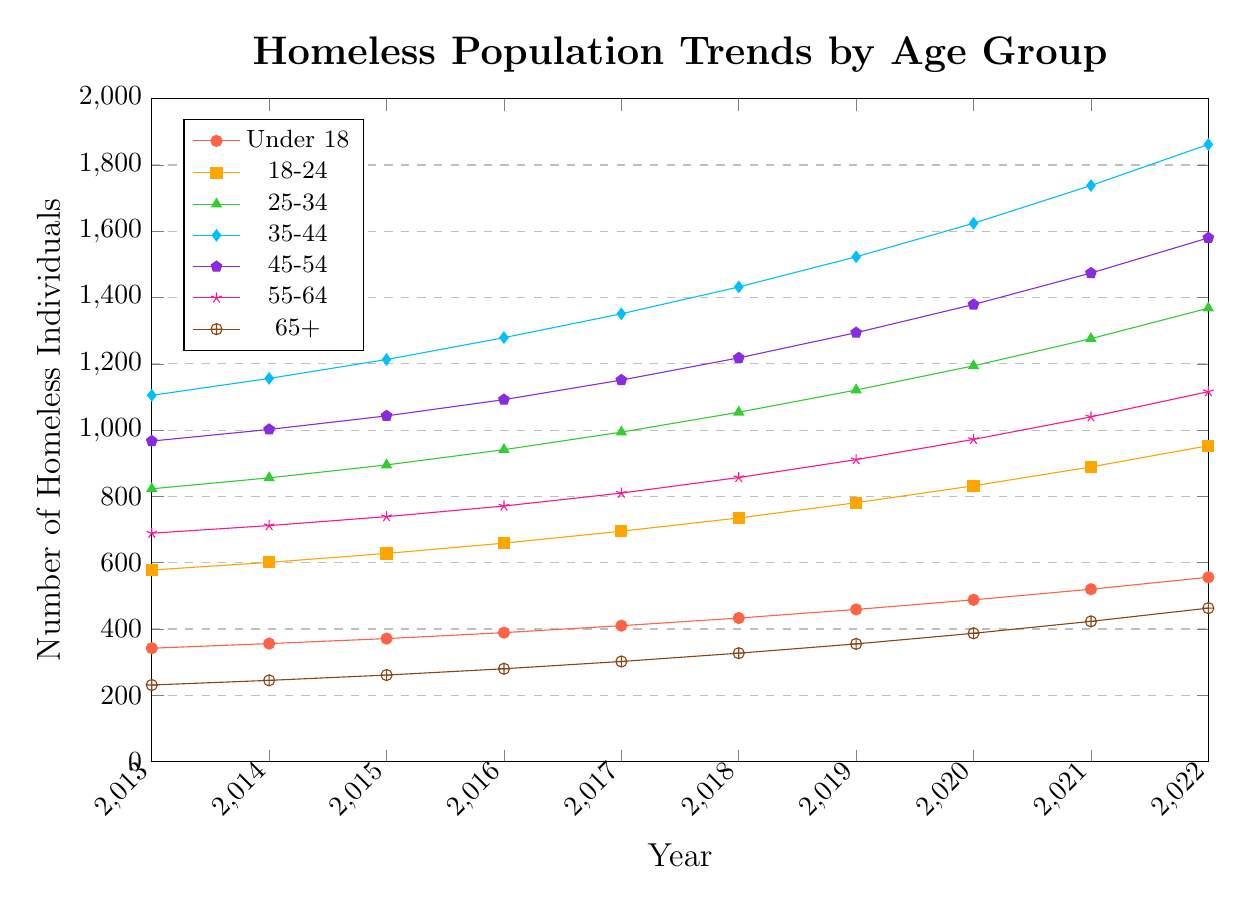What is the general trend in the number of homeless individuals for age group 25-34 over the past decade? The number of homeless individuals in the 25-34 age group increases each year, starting from 823 in 2013 and reaching 1368 in 2022. This can be observed by tracing the curve for 25-34 from the beginning to the end.
Answer: Increasing Which age group had the highest number of homeless individuals in 2022? In 2022, the 35-44 age group has the highest number of homeless individuals, with 1862, visible as the highest point on the plot.
Answer: 35-44 In 2020, were there more homeless individuals in the 18-24 age group or the 45-54 age group? By comparing the two plots, the 45-54 age group had 1379 homeless individuals in 2020, which is more than the 18-24 age group, which had 832.
Answer: 45-54 How much did the number of homeless individuals in the Under 18 age group increase from 2015 to 2022? In 2015, there were 371 homeless individuals in the Under 18 age group, and by 2022 there were 556. The increase can be calculated as 556 - 371 = 185.
Answer: 185 In which year did the 35-44 age group surpass 1500 homeless individuals? The number for the 35-44 age group surpassed 1500 in the year 2019 when it reached 1523, as seen on the graph by tracing the curve for the 35-44 age group.
Answer: 2019 On average, how many new homeless individuals were added per year in the 55-64 age group from 2013 to 2022? The number of individuals in 2013 and 2022 for the 55-64 age group were 689 and 1116 respectively. The total increase is 1116 - 689 = 427 over 9 years (2022 - 2013). The average increase per year is 427 / 9 ≈ 47.44.
Answer: 47.44 Which age group had the smallest increase in the number of homeless individuals from 2013 to 2022? The homeless population for the 65+ age group increased from 231 in 2013 to 463 in 2022. The increase is 463 - 231 = 232. Comparing increases across groups, 65+ has the smallest increase.
Answer: 65+ How did the number of homeless individuals in the 45-54 age group change from 2016 to 2018? The number of homeless individuals in the 45-54 age group increased from 1092 in 2016 to 1218 in 2018. The increase was 1218 - 1092 = 126.
Answer: 126 Which age group showed the greatest increase in homeless individuals from 2016 to 2020? Comparing increases from 2016 to 2020: Under 18 increased by 99, 18-24 increased by 173, 25-34 increased by 253, 35-44 increased by 345, 45-54 increased by 287, 55-64 increased by 201, and 65+ increased by 107. The 35-44 age group had the greatest increase, with 345.
Answer: 35-44 Which two age groups had the closest number of homeless individuals in 2015, and what were those numbers? In 2015, the number of homeless individuals in the 45-54 and 55-64 age groups were 1043 and 739, respectively. The closest numbers are for 25-34 (895) and 35-44 (1213). The closest pairs are 18-24 and 45-54.
Answer: 18-24 and 45-54 